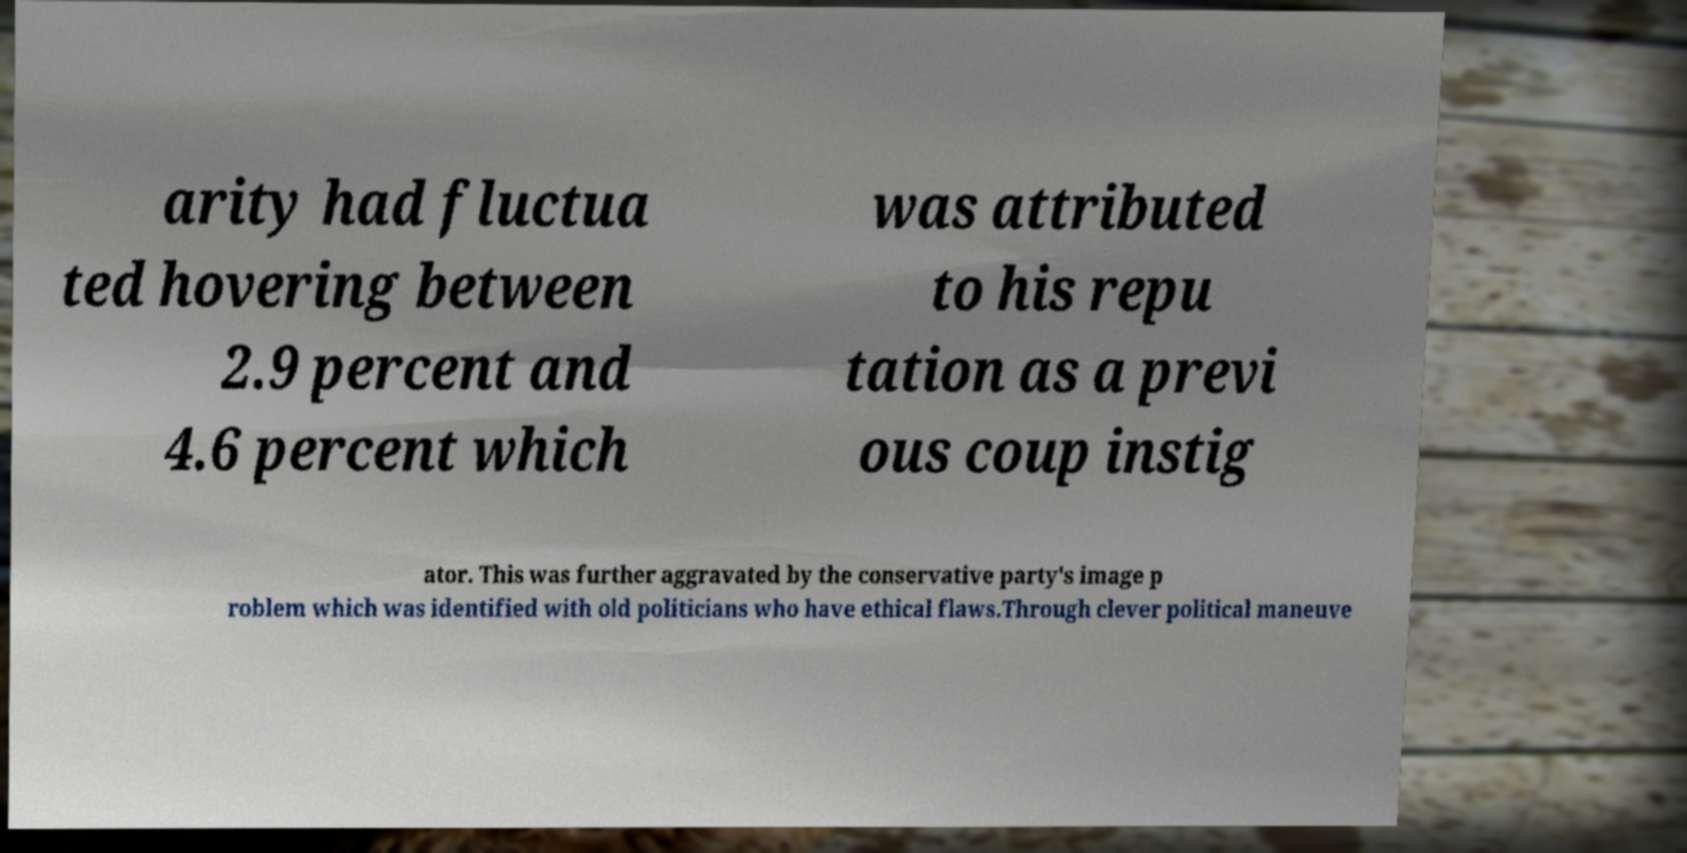Please identify and transcribe the text found in this image. arity had fluctua ted hovering between 2.9 percent and 4.6 percent which was attributed to his repu tation as a previ ous coup instig ator. This was further aggravated by the conservative party's image p roblem which was identified with old politicians who have ethical flaws.Through clever political maneuve 